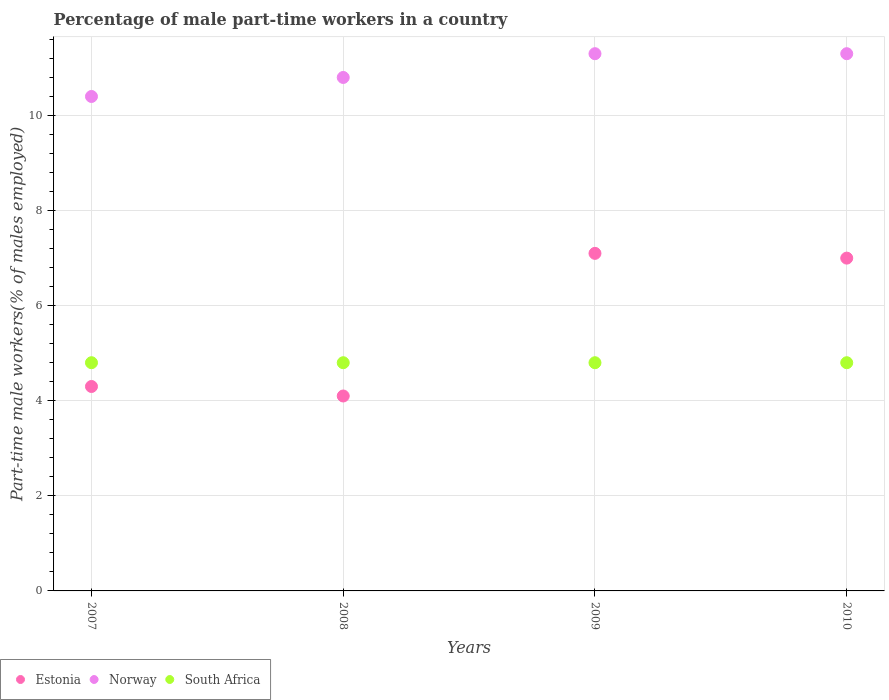What is the percentage of male part-time workers in Estonia in 2009?
Offer a terse response. 7.1. Across all years, what is the maximum percentage of male part-time workers in South Africa?
Provide a short and direct response. 4.8. Across all years, what is the minimum percentage of male part-time workers in South Africa?
Provide a short and direct response. 4.8. What is the total percentage of male part-time workers in Norway in the graph?
Offer a terse response. 43.8. What is the difference between the percentage of male part-time workers in Norway in 2007 and the percentage of male part-time workers in South Africa in 2009?
Make the answer very short. 5.6. What is the average percentage of male part-time workers in South Africa per year?
Ensure brevity in your answer.  4.8. In the year 2010, what is the difference between the percentage of male part-time workers in Estonia and percentage of male part-time workers in South Africa?
Offer a terse response. 2.2. What is the difference between the highest and the second highest percentage of male part-time workers in Estonia?
Make the answer very short. 0.1. What is the difference between the highest and the lowest percentage of male part-time workers in Estonia?
Provide a succinct answer. 3. In how many years, is the percentage of male part-time workers in Norway greater than the average percentage of male part-time workers in Norway taken over all years?
Your answer should be very brief. 2. Is it the case that in every year, the sum of the percentage of male part-time workers in Norway and percentage of male part-time workers in Estonia  is greater than the percentage of male part-time workers in South Africa?
Offer a very short reply. Yes. How many dotlines are there?
Your response must be concise. 3. How many years are there in the graph?
Your response must be concise. 4. Are the values on the major ticks of Y-axis written in scientific E-notation?
Your answer should be compact. No. Does the graph contain grids?
Give a very brief answer. Yes. Where does the legend appear in the graph?
Give a very brief answer. Bottom left. What is the title of the graph?
Keep it short and to the point. Percentage of male part-time workers in a country. What is the label or title of the Y-axis?
Provide a short and direct response. Part-time male workers(% of males employed). What is the Part-time male workers(% of males employed) in Estonia in 2007?
Your answer should be very brief. 4.3. What is the Part-time male workers(% of males employed) of Norway in 2007?
Your answer should be compact. 10.4. What is the Part-time male workers(% of males employed) of South Africa in 2007?
Offer a very short reply. 4.8. What is the Part-time male workers(% of males employed) in Estonia in 2008?
Make the answer very short. 4.1. What is the Part-time male workers(% of males employed) in Norway in 2008?
Make the answer very short. 10.8. What is the Part-time male workers(% of males employed) of South Africa in 2008?
Your response must be concise. 4.8. What is the Part-time male workers(% of males employed) in Estonia in 2009?
Provide a succinct answer. 7.1. What is the Part-time male workers(% of males employed) in Norway in 2009?
Ensure brevity in your answer.  11.3. What is the Part-time male workers(% of males employed) of South Africa in 2009?
Offer a terse response. 4.8. What is the Part-time male workers(% of males employed) in Norway in 2010?
Provide a succinct answer. 11.3. What is the Part-time male workers(% of males employed) in South Africa in 2010?
Provide a short and direct response. 4.8. Across all years, what is the maximum Part-time male workers(% of males employed) of Estonia?
Ensure brevity in your answer.  7.1. Across all years, what is the maximum Part-time male workers(% of males employed) in Norway?
Ensure brevity in your answer.  11.3. Across all years, what is the maximum Part-time male workers(% of males employed) in South Africa?
Your response must be concise. 4.8. Across all years, what is the minimum Part-time male workers(% of males employed) in Estonia?
Keep it short and to the point. 4.1. Across all years, what is the minimum Part-time male workers(% of males employed) in Norway?
Keep it short and to the point. 10.4. Across all years, what is the minimum Part-time male workers(% of males employed) of South Africa?
Make the answer very short. 4.8. What is the total Part-time male workers(% of males employed) in Estonia in the graph?
Make the answer very short. 22.5. What is the total Part-time male workers(% of males employed) in Norway in the graph?
Make the answer very short. 43.8. What is the difference between the Part-time male workers(% of males employed) in Estonia in 2007 and that in 2008?
Offer a very short reply. 0.2. What is the difference between the Part-time male workers(% of males employed) in Estonia in 2007 and that in 2010?
Offer a very short reply. -2.7. What is the difference between the Part-time male workers(% of males employed) in Norway in 2007 and that in 2010?
Give a very brief answer. -0.9. What is the difference between the Part-time male workers(% of males employed) of South Africa in 2008 and that in 2009?
Make the answer very short. 0. What is the difference between the Part-time male workers(% of males employed) of Estonia in 2008 and that in 2010?
Give a very brief answer. -2.9. What is the difference between the Part-time male workers(% of males employed) in Estonia in 2009 and that in 2010?
Your answer should be very brief. 0.1. What is the difference between the Part-time male workers(% of males employed) in South Africa in 2009 and that in 2010?
Your response must be concise. 0. What is the difference between the Part-time male workers(% of males employed) of Estonia in 2007 and the Part-time male workers(% of males employed) of Norway in 2008?
Give a very brief answer. -6.5. What is the difference between the Part-time male workers(% of males employed) of Estonia in 2007 and the Part-time male workers(% of males employed) of South Africa in 2008?
Make the answer very short. -0.5. What is the difference between the Part-time male workers(% of males employed) of Norway in 2007 and the Part-time male workers(% of males employed) of South Africa in 2008?
Offer a terse response. 5.6. What is the difference between the Part-time male workers(% of males employed) in Estonia in 2007 and the Part-time male workers(% of males employed) in Norway in 2009?
Offer a terse response. -7. What is the difference between the Part-time male workers(% of males employed) of Estonia in 2007 and the Part-time male workers(% of males employed) of South Africa in 2010?
Your response must be concise. -0.5. What is the difference between the Part-time male workers(% of males employed) in Estonia in 2008 and the Part-time male workers(% of males employed) in South Africa in 2009?
Provide a succinct answer. -0.7. What is the difference between the Part-time male workers(% of males employed) in Norway in 2008 and the Part-time male workers(% of males employed) in South Africa in 2009?
Offer a very short reply. 6. What is the difference between the Part-time male workers(% of males employed) in Estonia in 2008 and the Part-time male workers(% of males employed) in South Africa in 2010?
Your answer should be compact. -0.7. What is the difference between the Part-time male workers(% of males employed) of Estonia in 2009 and the Part-time male workers(% of males employed) of Norway in 2010?
Your answer should be compact. -4.2. What is the average Part-time male workers(% of males employed) in Estonia per year?
Your answer should be compact. 5.62. What is the average Part-time male workers(% of males employed) of Norway per year?
Your answer should be very brief. 10.95. In the year 2007, what is the difference between the Part-time male workers(% of males employed) of Estonia and Part-time male workers(% of males employed) of South Africa?
Provide a short and direct response. -0.5. In the year 2007, what is the difference between the Part-time male workers(% of males employed) of Norway and Part-time male workers(% of males employed) of South Africa?
Your answer should be very brief. 5.6. In the year 2008, what is the difference between the Part-time male workers(% of males employed) in Estonia and Part-time male workers(% of males employed) in Norway?
Offer a very short reply. -6.7. In the year 2009, what is the difference between the Part-time male workers(% of males employed) of Estonia and Part-time male workers(% of males employed) of Norway?
Give a very brief answer. -4.2. In the year 2009, what is the difference between the Part-time male workers(% of males employed) in Estonia and Part-time male workers(% of males employed) in South Africa?
Your response must be concise. 2.3. In the year 2010, what is the difference between the Part-time male workers(% of males employed) in Estonia and Part-time male workers(% of males employed) in South Africa?
Offer a terse response. 2.2. In the year 2010, what is the difference between the Part-time male workers(% of males employed) of Norway and Part-time male workers(% of males employed) of South Africa?
Make the answer very short. 6.5. What is the ratio of the Part-time male workers(% of males employed) of Estonia in 2007 to that in 2008?
Your response must be concise. 1.05. What is the ratio of the Part-time male workers(% of males employed) in Norway in 2007 to that in 2008?
Provide a short and direct response. 0.96. What is the ratio of the Part-time male workers(% of males employed) in South Africa in 2007 to that in 2008?
Offer a very short reply. 1. What is the ratio of the Part-time male workers(% of males employed) in Estonia in 2007 to that in 2009?
Your answer should be very brief. 0.61. What is the ratio of the Part-time male workers(% of males employed) of Norway in 2007 to that in 2009?
Give a very brief answer. 0.92. What is the ratio of the Part-time male workers(% of males employed) of Estonia in 2007 to that in 2010?
Provide a succinct answer. 0.61. What is the ratio of the Part-time male workers(% of males employed) of Norway in 2007 to that in 2010?
Make the answer very short. 0.92. What is the ratio of the Part-time male workers(% of males employed) of Estonia in 2008 to that in 2009?
Give a very brief answer. 0.58. What is the ratio of the Part-time male workers(% of males employed) in Norway in 2008 to that in 2009?
Your response must be concise. 0.96. What is the ratio of the Part-time male workers(% of males employed) in Estonia in 2008 to that in 2010?
Offer a very short reply. 0.59. What is the ratio of the Part-time male workers(% of males employed) in Norway in 2008 to that in 2010?
Your response must be concise. 0.96. What is the ratio of the Part-time male workers(% of males employed) of Estonia in 2009 to that in 2010?
Give a very brief answer. 1.01. What is the ratio of the Part-time male workers(% of males employed) in South Africa in 2009 to that in 2010?
Keep it short and to the point. 1. What is the difference between the highest and the second highest Part-time male workers(% of males employed) in Norway?
Keep it short and to the point. 0. What is the difference between the highest and the lowest Part-time male workers(% of males employed) of Estonia?
Provide a succinct answer. 3. What is the difference between the highest and the lowest Part-time male workers(% of males employed) in Norway?
Keep it short and to the point. 0.9. What is the difference between the highest and the lowest Part-time male workers(% of males employed) of South Africa?
Keep it short and to the point. 0. 